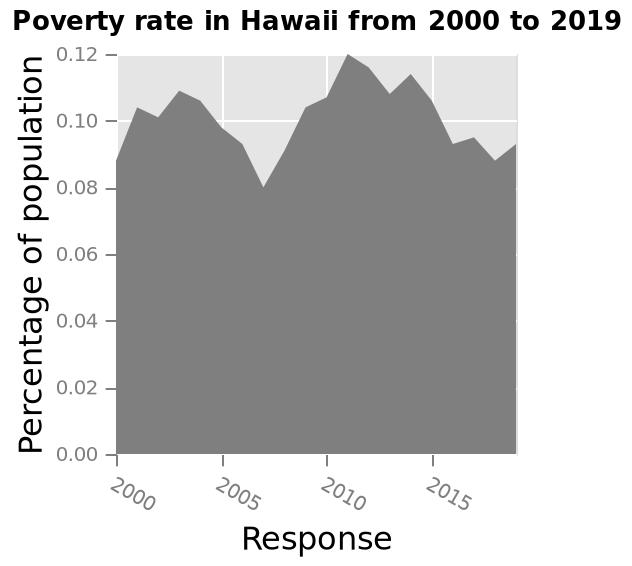<image>
What is the poverty rate in 2007? 0.08% How does the poverty rate in 2011 compare to that in 2007? The poverty rate in 2011 is higher than that in 2007. 